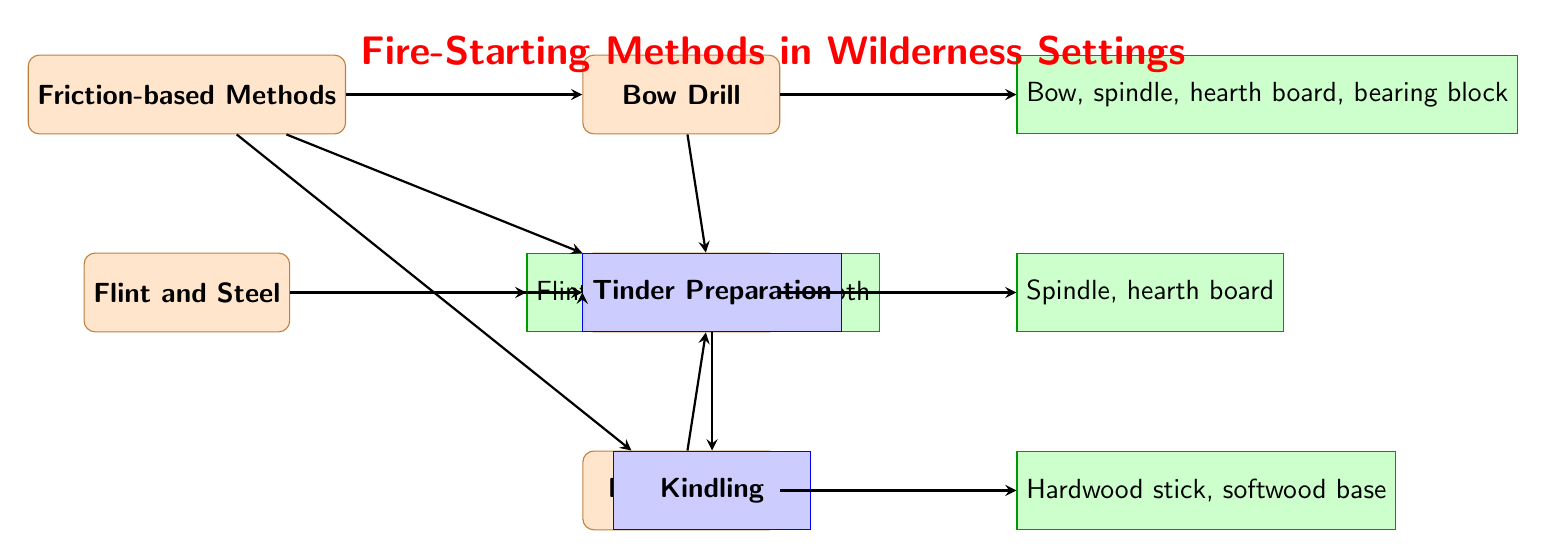What are the methods of fire-starting depicted in the diagram? The diagram shows two main methods for fire-starting: Friction-based Methods and Flint and Steel. These are the top-level categories represented as rectangles at the top of the diagram.
Answer: Friction-based Methods, Flint and Steel How many friction-based methods are illustrated in the diagram? There are three friction-based methods illustrated: Bow Drill, Hand Drill, and Fire Plough. These methods are positioned below the Friction-based Methods rectangle.
Answer: 3 What materials are required for the Bow Drill method? The materials required for the Bow Drill method, as indicated in the diagram, are Bow, spindle, hearth board, and bearing block. This information is shown in the rectangle connected to the Bow Drill rectangle.
Answer: Bow, spindle, hearth board, bearing block Which method leads to Tinder Preparation? The diagram illustrates that all methods, including Bow Drill, Hand Drill, Fire Plough, and Flint and Steel, lead to the process of Tinder Preparation, as shown by the arrows connecting the methods' rectangles to the Tinder Preparation rectangle.
Answer: All methods What process follows Tinder Preparation in the diagram? The process indicated to follow Tinder Preparation in the diagram is Kindling. The arrow directly connecting the Tinder Preparation rectangle to the Kindling rectangle demonstrates this order in the progression of fire-starting.
Answer: Kindling What is the color representing the process nodes in the diagram? The process nodes in the diagram are filled with blue color. This is visually evident by looking at the rectangles labeled as Tinder Preparation and Kindling, which are colored blue according to the diagram's style settings.
Answer: Blue Which fire-starting method uses char cloth as a material? The Flint and Steel method uses char cloth, as shown in the materials rectangle connected to the Flint and Steel rectangle. The mention of char cloth specifically indicates its necessity for this method.
Answer: Char cloth How many materials are listed for the Fire Plough method? There are two materials listed for the Fire Plough method: hardwood stick and softwood base. This can be seen directly in the materials rectangle associated with the Fire Plough method in the diagram.
Answer: 2 